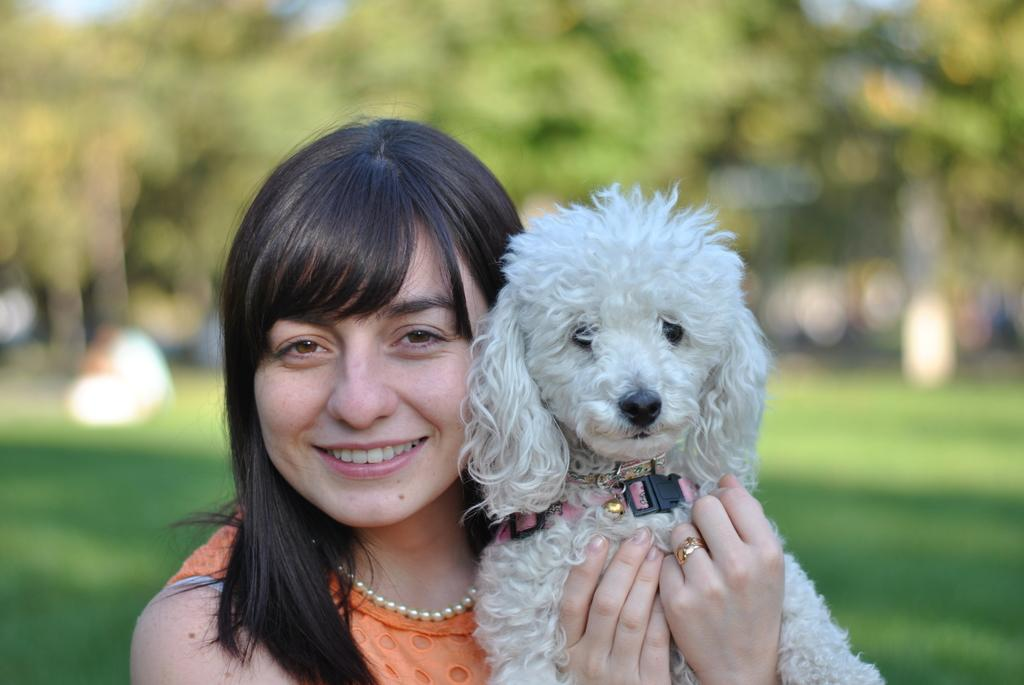Who is present in the image? There is a woman in the image. What is the woman wearing? The woman is wearing an orange dress. What is the woman holding in the image? The woman is holding a puppy. What can be seen in the background of the image? There are trees and grass in the background of the image. What type of kite is the woman flying in the image? There is no kite present in the image; the woman is holding a puppy. 